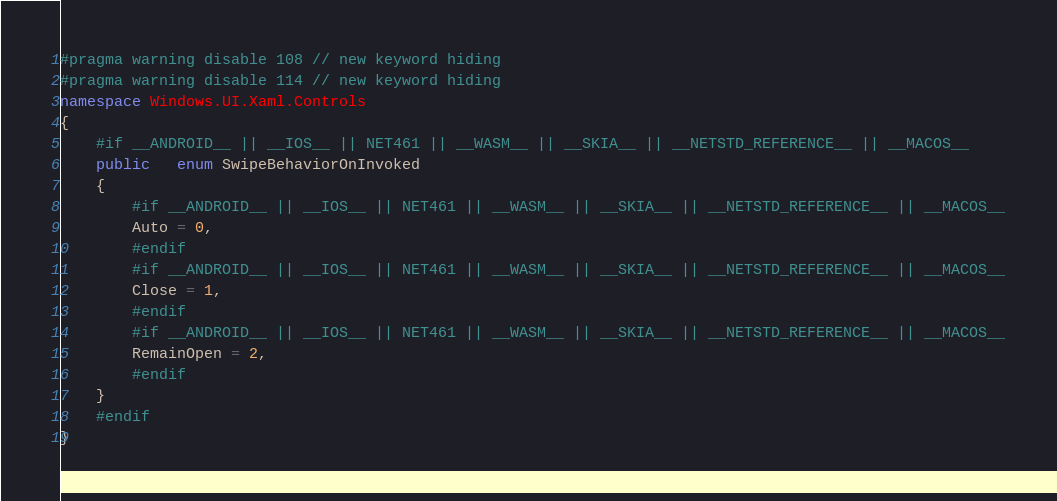Convert code to text. <code><loc_0><loc_0><loc_500><loc_500><_C#_>#pragma warning disable 108 // new keyword hiding
#pragma warning disable 114 // new keyword hiding
namespace Windows.UI.Xaml.Controls
{
	#if __ANDROID__ || __IOS__ || NET461 || __WASM__ || __SKIA__ || __NETSTD_REFERENCE__ || __MACOS__
	public   enum SwipeBehaviorOnInvoked 
	{
		#if __ANDROID__ || __IOS__ || NET461 || __WASM__ || __SKIA__ || __NETSTD_REFERENCE__ || __MACOS__
		Auto = 0,
		#endif
		#if __ANDROID__ || __IOS__ || NET461 || __WASM__ || __SKIA__ || __NETSTD_REFERENCE__ || __MACOS__
		Close = 1,
		#endif
		#if __ANDROID__ || __IOS__ || NET461 || __WASM__ || __SKIA__ || __NETSTD_REFERENCE__ || __MACOS__
		RemainOpen = 2,
		#endif
	}
	#endif
}
</code> 